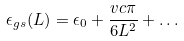Convert formula to latex. <formula><loc_0><loc_0><loc_500><loc_500>\epsilon _ { g s } ( L ) = \epsilon _ { 0 } + \frac { v c \pi } { 6 L ^ { 2 } } + \dots</formula> 